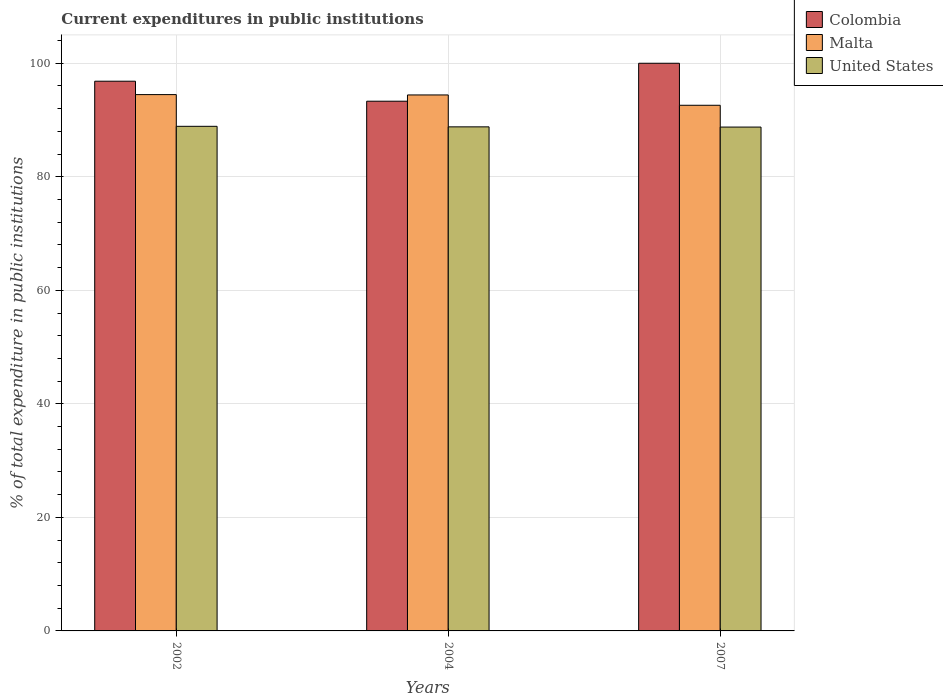How many groups of bars are there?
Your answer should be very brief. 3. How many bars are there on the 1st tick from the left?
Your response must be concise. 3. In how many cases, is the number of bars for a given year not equal to the number of legend labels?
Make the answer very short. 0. What is the current expenditures in public institutions in United States in 2004?
Make the answer very short. 88.8. Across all years, what is the maximum current expenditures in public institutions in Colombia?
Your answer should be very brief. 100. Across all years, what is the minimum current expenditures in public institutions in United States?
Provide a succinct answer. 88.76. In which year was the current expenditures in public institutions in Colombia maximum?
Provide a short and direct response. 2007. In which year was the current expenditures in public institutions in United States minimum?
Offer a very short reply. 2007. What is the total current expenditures in public institutions in United States in the graph?
Keep it short and to the point. 266.45. What is the difference between the current expenditures in public institutions in Colombia in 2004 and that in 2007?
Your answer should be very brief. -6.69. What is the difference between the current expenditures in public institutions in Colombia in 2002 and the current expenditures in public institutions in Malta in 2004?
Ensure brevity in your answer.  2.42. What is the average current expenditures in public institutions in Malta per year?
Provide a short and direct response. 93.83. In the year 2004, what is the difference between the current expenditures in public institutions in Malta and current expenditures in public institutions in United States?
Provide a succinct answer. 5.62. What is the ratio of the current expenditures in public institutions in Malta in 2004 to that in 2007?
Offer a terse response. 1.02. Is the current expenditures in public institutions in Colombia in 2002 less than that in 2004?
Provide a succinct answer. No. What is the difference between the highest and the second highest current expenditures in public institutions in Colombia?
Ensure brevity in your answer.  3.16. What is the difference between the highest and the lowest current expenditures in public institutions in Colombia?
Your response must be concise. 6.69. What does the 2nd bar from the left in 2007 represents?
Your answer should be compact. Malta. What does the 2nd bar from the right in 2002 represents?
Provide a succinct answer. Malta. Is it the case that in every year, the sum of the current expenditures in public institutions in Malta and current expenditures in public institutions in Colombia is greater than the current expenditures in public institutions in United States?
Provide a short and direct response. Yes. Are all the bars in the graph horizontal?
Offer a very short reply. No. How many years are there in the graph?
Your response must be concise. 3. What is the difference between two consecutive major ticks on the Y-axis?
Your response must be concise. 20. Are the values on the major ticks of Y-axis written in scientific E-notation?
Your answer should be very brief. No. Does the graph contain grids?
Offer a very short reply. Yes. What is the title of the graph?
Your answer should be very brief. Current expenditures in public institutions. Does "Lithuania" appear as one of the legend labels in the graph?
Provide a short and direct response. No. What is the label or title of the X-axis?
Offer a terse response. Years. What is the label or title of the Y-axis?
Your response must be concise. % of total expenditure in public institutions. What is the % of total expenditure in public institutions of Colombia in 2002?
Keep it short and to the point. 96.84. What is the % of total expenditure in public institutions in Malta in 2002?
Provide a succinct answer. 94.48. What is the % of total expenditure in public institutions of United States in 2002?
Your answer should be very brief. 88.89. What is the % of total expenditure in public institutions of Colombia in 2004?
Make the answer very short. 93.31. What is the % of total expenditure in public institutions of Malta in 2004?
Keep it short and to the point. 94.42. What is the % of total expenditure in public institutions of United States in 2004?
Offer a very short reply. 88.8. What is the % of total expenditure in public institutions of Colombia in 2007?
Offer a very short reply. 100. What is the % of total expenditure in public institutions in Malta in 2007?
Offer a terse response. 92.6. What is the % of total expenditure in public institutions in United States in 2007?
Offer a very short reply. 88.76. Across all years, what is the maximum % of total expenditure in public institutions in Malta?
Your answer should be very brief. 94.48. Across all years, what is the maximum % of total expenditure in public institutions in United States?
Offer a very short reply. 88.89. Across all years, what is the minimum % of total expenditure in public institutions in Colombia?
Your answer should be very brief. 93.31. Across all years, what is the minimum % of total expenditure in public institutions in Malta?
Your answer should be compact. 92.6. Across all years, what is the minimum % of total expenditure in public institutions in United States?
Ensure brevity in your answer.  88.76. What is the total % of total expenditure in public institutions in Colombia in the graph?
Provide a succinct answer. 290.15. What is the total % of total expenditure in public institutions of Malta in the graph?
Your answer should be compact. 281.49. What is the total % of total expenditure in public institutions in United States in the graph?
Your response must be concise. 266.45. What is the difference between the % of total expenditure in public institutions in Colombia in 2002 and that in 2004?
Offer a terse response. 3.52. What is the difference between the % of total expenditure in public institutions of Malta in 2002 and that in 2004?
Give a very brief answer. 0.06. What is the difference between the % of total expenditure in public institutions in United States in 2002 and that in 2004?
Offer a very short reply. 0.09. What is the difference between the % of total expenditure in public institutions of Colombia in 2002 and that in 2007?
Your answer should be compact. -3.16. What is the difference between the % of total expenditure in public institutions in Malta in 2002 and that in 2007?
Keep it short and to the point. 1.88. What is the difference between the % of total expenditure in public institutions in United States in 2002 and that in 2007?
Offer a very short reply. 0.13. What is the difference between the % of total expenditure in public institutions in Colombia in 2004 and that in 2007?
Your answer should be very brief. -6.68. What is the difference between the % of total expenditure in public institutions in Malta in 2004 and that in 2007?
Your answer should be very brief. 1.82. What is the difference between the % of total expenditure in public institutions in United States in 2004 and that in 2007?
Provide a short and direct response. 0.04. What is the difference between the % of total expenditure in public institutions of Colombia in 2002 and the % of total expenditure in public institutions of Malta in 2004?
Provide a succinct answer. 2.42. What is the difference between the % of total expenditure in public institutions in Colombia in 2002 and the % of total expenditure in public institutions in United States in 2004?
Make the answer very short. 8.04. What is the difference between the % of total expenditure in public institutions in Malta in 2002 and the % of total expenditure in public institutions in United States in 2004?
Make the answer very short. 5.68. What is the difference between the % of total expenditure in public institutions of Colombia in 2002 and the % of total expenditure in public institutions of Malta in 2007?
Your answer should be compact. 4.24. What is the difference between the % of total expenditure in public institutions in Colombia in 2002 and the % of total expenditure in public institutions in United States in 2007?
Offer a terse response. 8.08. What is the difference between the % of total expenditure in public institutions of Malta in 2002 and the % of total expenditure in public institutions of United States in 2007?
Make the answer very short. 5.72. What is the difference between the % of total expenditure in public institutions in Colombia in 2004 and the % of total expenditure in public institutions in Malta in 2007?
Provide a succinct answer. 0.72. What is the difference between the % of total expenditure in public institutions in Colombia in 2004 and the % of total expenditure in public institutions in United States in 2007?
Offer a terse response. 4.56. What is the difference between the % of total expenditure in public institutions in Malta in 2004 and the % of total expenditure in public institutions in United States in 2007?
Offer a terse response. 5.66. What is the average % of total expenditure in public institutions of Colombia per year?
Your response must be concise. 96.72. What is the average % of total expenditure in public institutions of Malta per year?
Make the answer very short. 93.83. What is the average % of total expenditure in public institutions in United States per year?
Offer a terse response. 88.82. In the year 2002, what is the difference between the % of total expenditure in public institutions in Colombia and % of total expenditure in public institutions in Malta?
Provide a succinct answer. 2.36. In the year 2002, what is the difference between the % of total expenditure in public institutions of Colombia and % of total expenditure in public institutions of United States?
Keep it short and to the point. 7.95. In the year 2002, what is the difference between the % of total expenditure in public institutions of Malta and % of total expenditure in public institutions of United States?
Keep it short and to the point. 5.59. In the year 2004, what is the difference between the % of total expenditure in public institutions of Colombia and % of total expenditure in public institutions of Malta?
Give a very brief answer. -1.1. In the year 2004, what is the difference between the % of total expenditure in public institutions in Colombia and % of total expenditure in public institutions in United States?
Provide a short and direct response. 4.52. In the year 2004, what is the difference between the % of total expenditure in public institutions of Malta and % of total expenditure in public institutions of United States?
Give a very brief answer. 5.62. In the year 2007, what is the difference between the % of total expenditure in public institutions of Colombia and % of total expenditure in public institutions of Malta?
Ensure brevity in your answer.  7.4. In the year 2007, what is the difference between the % of total expenditure in public institutions of Colombia and % of total expenditure in public institutions of United States?
Offer a terse response. 11.24. In the year 2007, what is the difference between the % of total expenditure in public institutions in Malta and % of total expenditure in public institutions in United States?
Your answer should be compact. 3.84. What is the ratio of the % of total expenditure in public institutions in Colombia in 2002 to that in 2004?
Offer a very short reply. 1.04. What is the ratio of the % of total expenditure in public institutions of Colombia in 2002 to that in 2007?
Make the answer very short. 0.97. What is the ratio of the % of total expenditure in public institutions of Malta in 2002 to that in 2007?
Provide a short and direct response. 1.02. What is the ratio of the % of total expenditure in public institutions of Colombia in 2004 to that in 2007?
Your answer should be very brief. 0.93. What is the ratio of the % of total expenditure in public institutions of Malta in 2004 to that in 2007?
Provide a short and direct response. 1.02. What is the difference between the highest and the second highest % of total expenditure in public institutions of Colombia?
Your answer should be compact. 3.16. What is the difference between the highest and the second highest % of total expenditure in public institutions of Malta?
Make the answer very short. 0.06. What is the difference between the highest and the second highest % of total expenditure in public institutions in United States?
Offer a terse response. 0.09. What is the difference between the highest and the lowest % of total expenditure in public institutions in Colombia?
Your response must be concise. 6.68. What is the difference between the highest and the lowest % of total expenditure in public institutions in Malta?
Your answer should be very brief. 1.88. What is the difference between the highest and the lowest % of total expenditure in public institutions in United States?
Your response must be concise. 0.13. 